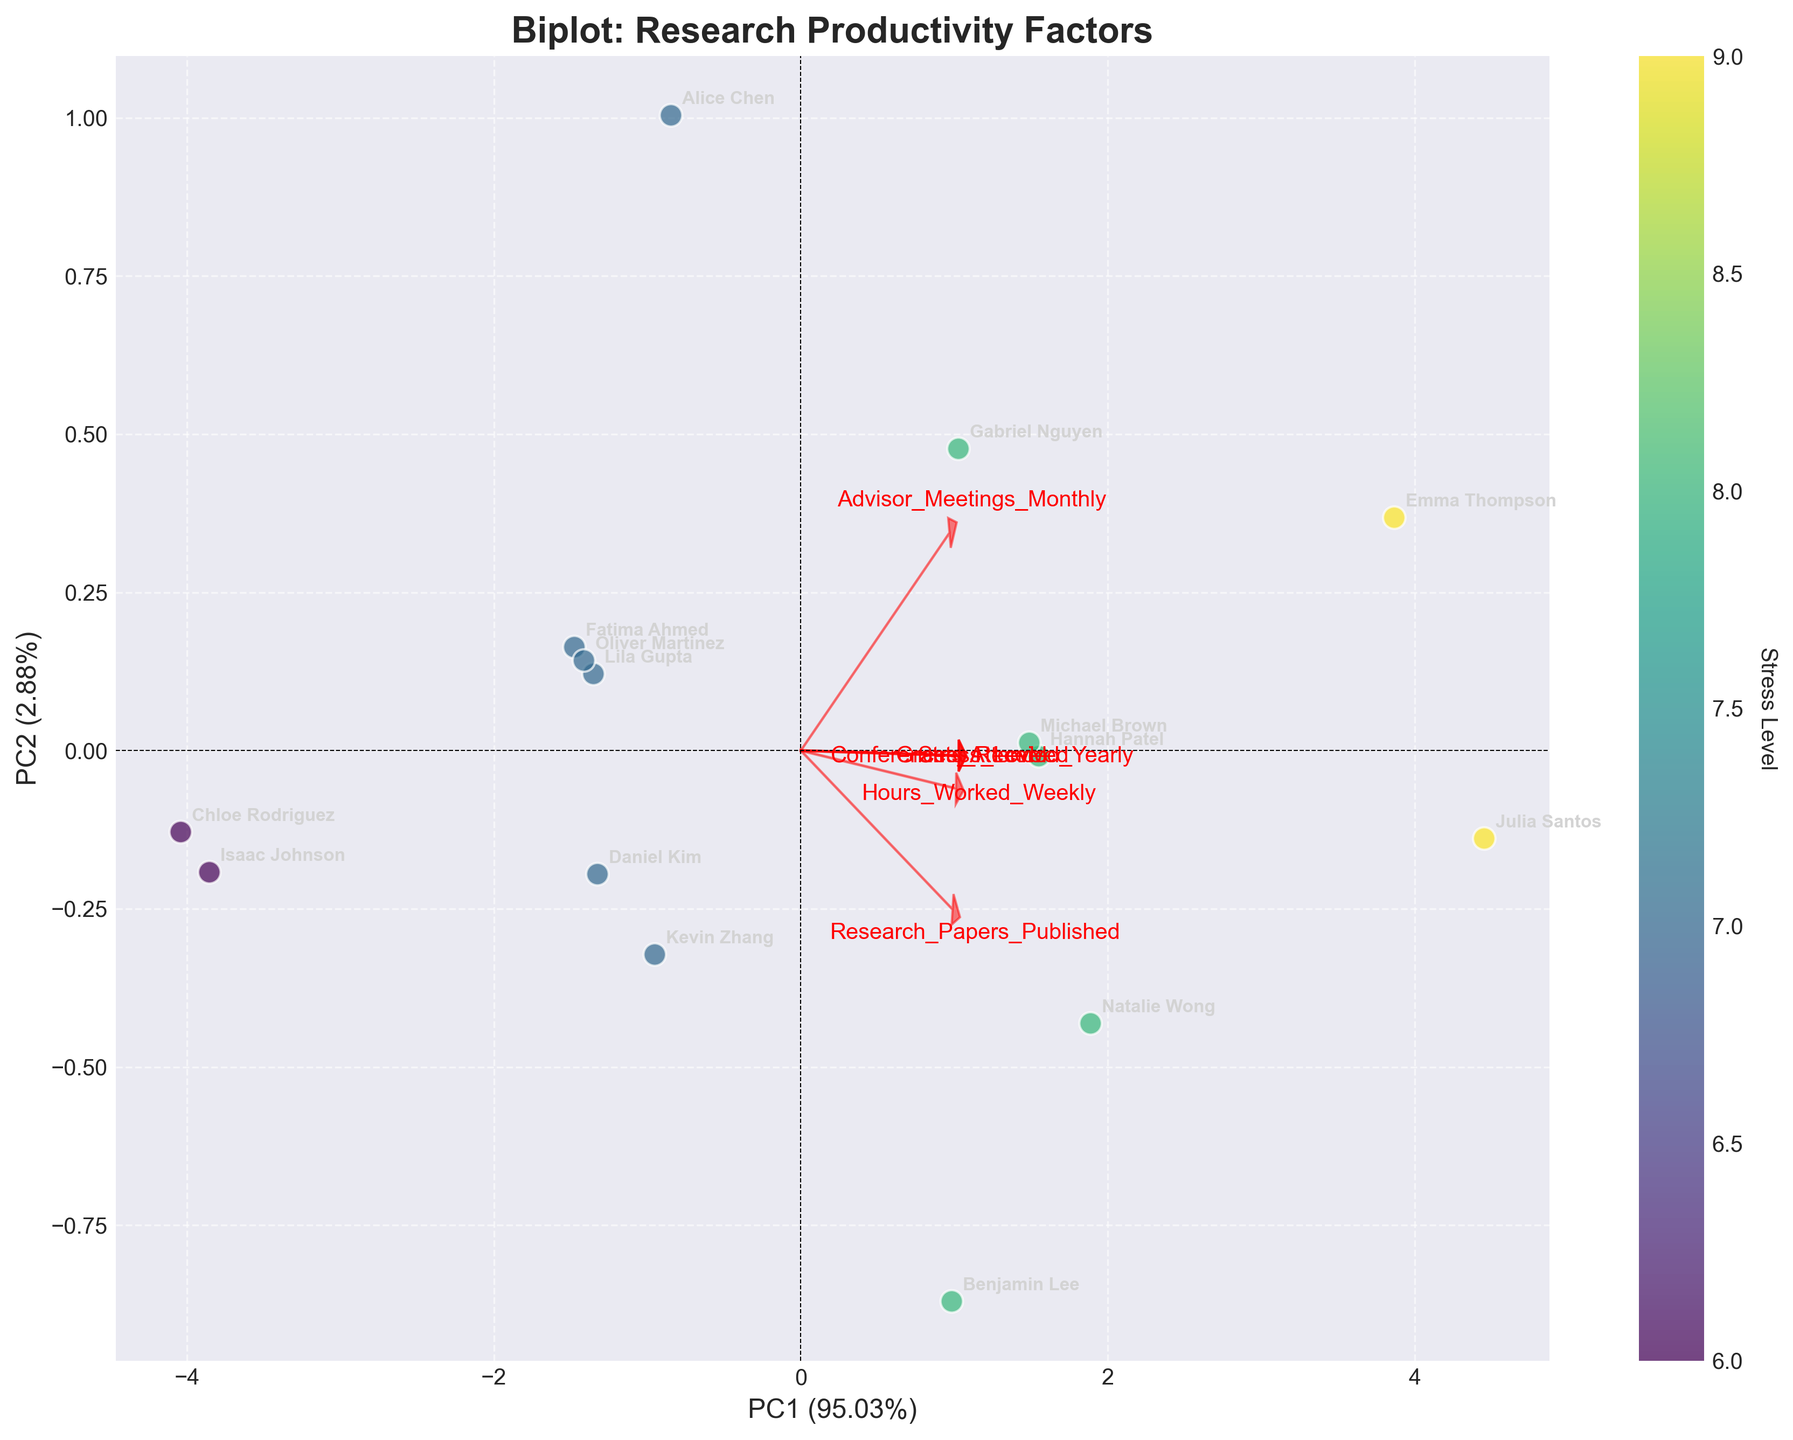How many different features are analyzed in the biplot? The biplot shows arrows representing different features affecting research productivity. Each arrow is labeled with the feature's name. Count the number of unique labels/features on the plot.
Answer: 6 Which feature appears to have the strongest relationship with the first principal component (PC1)? The strength of the relationship can be inferred from how aligned the arrows are with the PC1 axis. The arrow with the largest projection along PC1 indicates the feature with the strongest relationship.
Answer: Hours Worked Weekly How does the stress level seem to vary among the different students? Students are differentiated by circles of varying colors, representing their stress levels on a gradient from the color bar on the right. Gradually moving from lighter to darker colors indicates lower to higher stress levels. Look at the spread of these colors across the plot to infer the variation.
Answer: Varies, with some students having low, medium, and high levels of stress Which students are primarily contributing to the second principal component (PC2)? Students' contributions to PC2 can be inferred from their positions along the PC2 axis. Higher loading or score on the PC2 axis means greater contribution to PC2. Look for students farther from the origin along the PC2 axis.
Answer: Emma Thompson, Julia Santos Are students with more frequent advisor meetings publishing more research papers? Observe the arrows representing "Advisor Meetings Monthly" and "Research Papers Published." If the directions of these arrows align closely, it suggests a positive correlation. Then, check the positions of students aligned in this direction.
Answer: Yes, there is a positive correlation Which student has attended the most conferences yearly, and how does this correlate with their stress level? The feature "Conferences Attended Yearly" should be evaluated by the corresponding arrow direction. Identify students positioned along this direction. Additionally, note their stress level from the color gradient.
Answer: Emma Thompson, Julia Santos have attended the most; their stress levels are high Which features are negatively correlated with the stress level? Positive correlation with stress level means arrows are pointing in the same direction as stress arrows. Conversely, negative correlation means pointing in the opposite direction. Identify features opposite to stress level direction.
Answer: Advisor Meetings Monthly, Hours Worked Weekly What is the total number of data points (students) represented in the biplot? Each point on the biplot represents a student, identified by their names. Count the total number of unique points/names annotated on the plot.
Answer: 15 How does the number of research papers published vary with the amount of grants received? Observe the alignment between the arrows representing "Research Papers Published" and "Grants Received." If the arrows are nearly aligned, especially pointing in the same direction, it suggests a correlation.
Answer: Positive correlation Which feature shows the least variation among students according to the biplot? Look for the arrow with the smallest length; shorter arrows represent features with less variation among students, as they have smaller loadings on the principal components.
Answer: Grants Received 